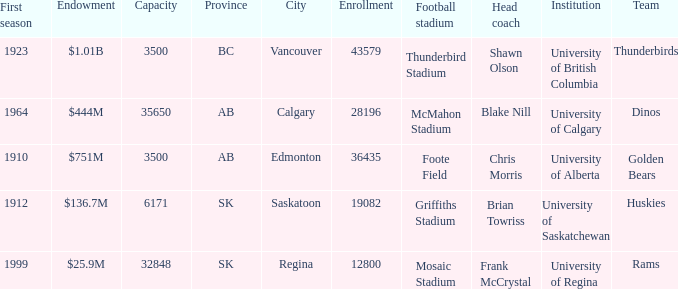What football stadium has a school enrollment of 43579? Thunderbird Stadium. 